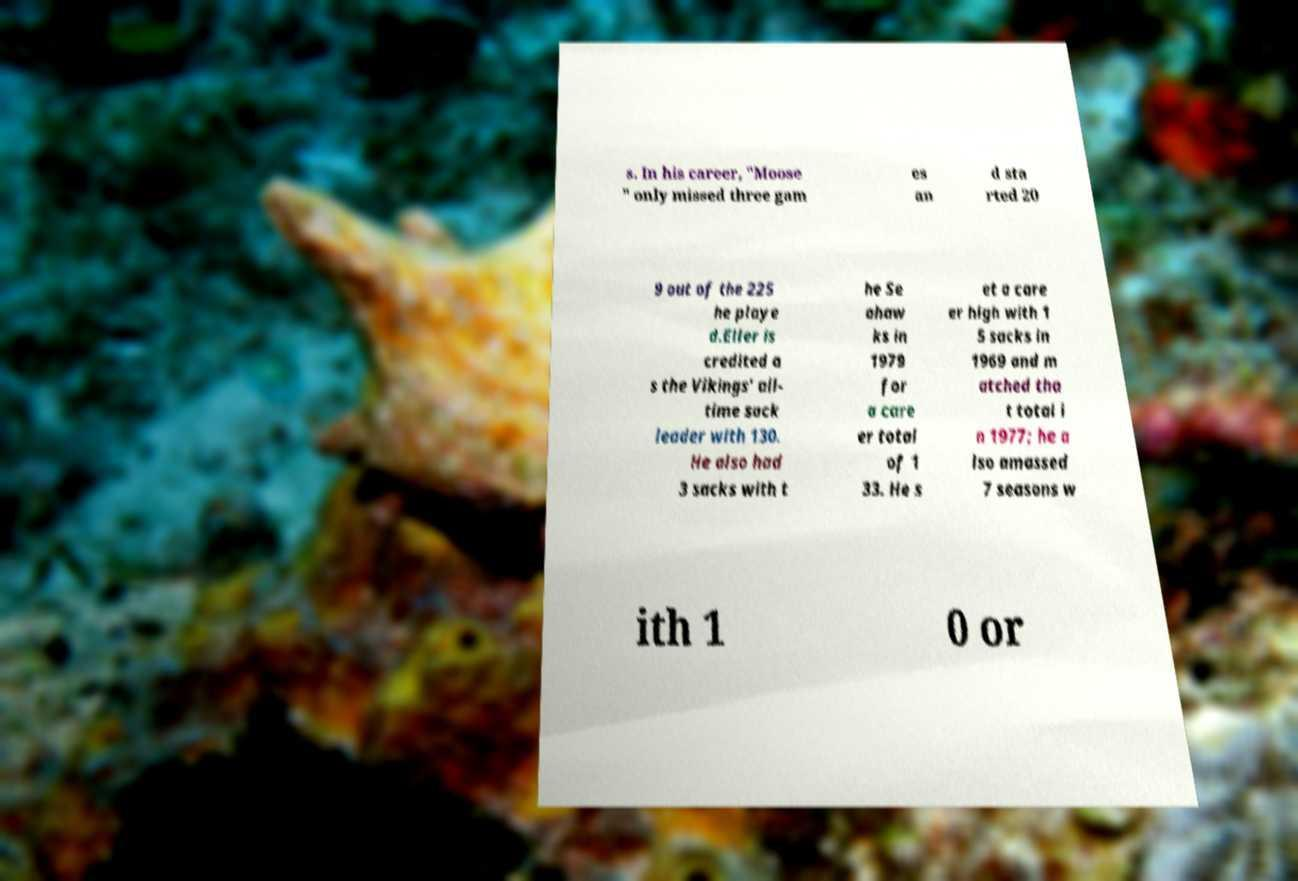I need the written content from this picture converted into text. Can you do that? s. In his career, "Moose " only missed three gam es an d sta rted 20 9 out of the 225 he playe d.Eller is credited a s the Vikings' all- time sack leader with 130. He also had 3 sacks with t he Se ahaw ks in 1979 for a care er total of 1 33. He s et a care er high with 1 5 sacks in 1969 and m atched tha t total i n 1977; he a lso amassed 7 seasons w ith 1 0 or 